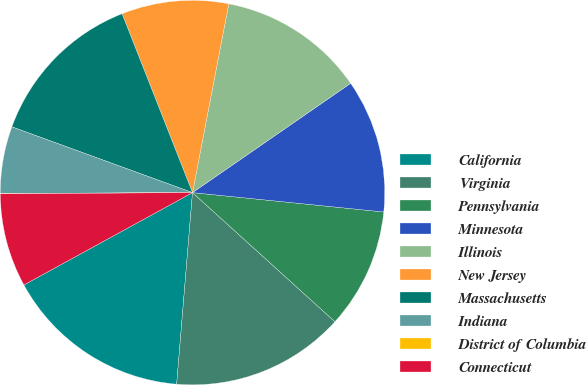Convert chart to OTSL. <chart><loc_0><loc_0><loc_500><loc_500><pie_chart><fcel>California<fcel>Virginia<fcel>Pennsylvania<fcel>Minnesota<fcel>Illinois<fcel>New Jersey<fcel>Massachusetts<fcel>Indiana<fcel>District of Columbia<fcel>Connecticut<nl><fcel>15.71%<fcel>14.59%<fcel>10.11%<fcel>11.23%<fcel>12.35%<fcel>8.99%<fcel>13.47%<fcel>5.63%<fcel>0.03%<fcel>7.87%<nl></chart> 